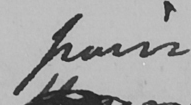Can you read and transcribe this handwriting? pain 